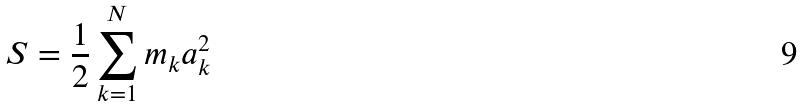Convert formula to latex. <formula><loc_0><loc_0><loc_500><loc_500>S = \frac { 1 } { 2 } \sum _ { k = 1 } ^ { N } m _ { k } a _ { k } ^ { 2 }</formula> 